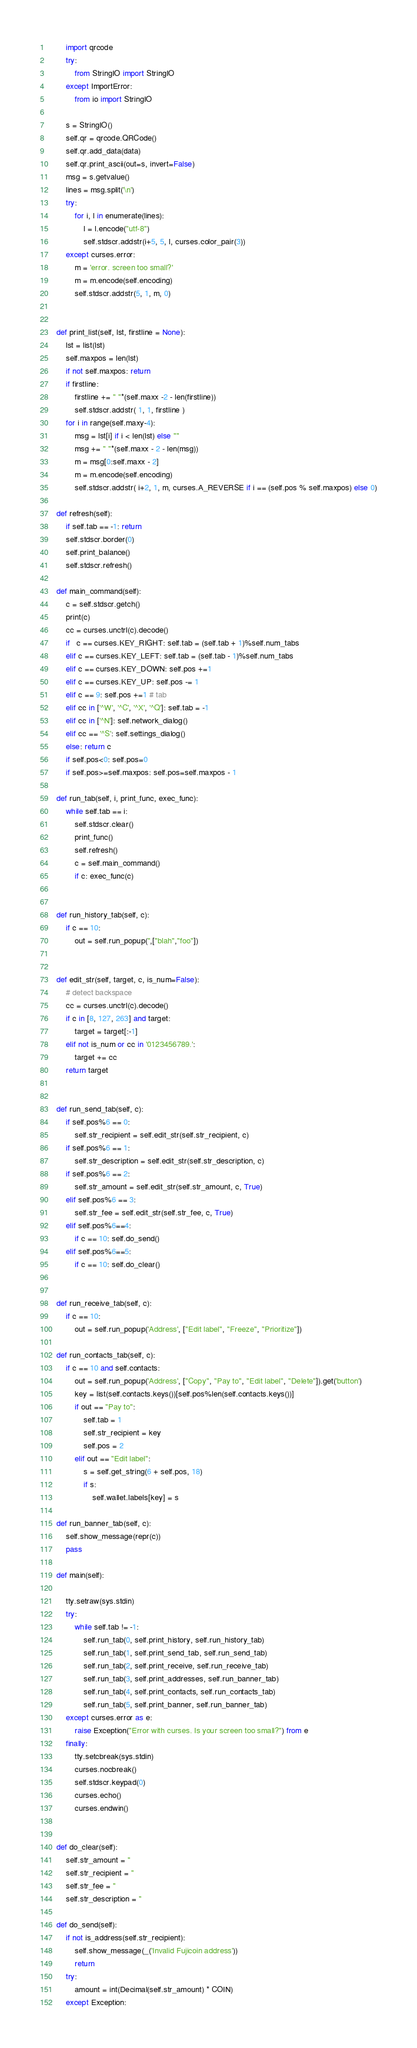Convert code to text. <code><loc_0><loc_0><loc_500><loc_500><_Python_>        import qrcode
        try:
            from StringIO import StringIO
        except ImportError:
            from io import StringIO

        s = StringIO()
        self.qr = qrcode.QRCode()
        self.qr.add_data(data)
        self.qr.print_ascii(out=s, invert=False)
        msg = s.getvalue()
        lines = msg.split('\n')
        try:
            for i, l in enumerate(lines):
                l = l.encode("utf-8")
                self.stdscr.addstr(i+5, 5, l, curses.color_pair(3))
        except curses.error:
            m = 'error. screen too small?'
            m = m.encode(self.encoding)
            self.stdscr.addstr(5, 1, m, 0)


    def print_list(self, lst, firstline = None):
        lst = list(lst)
        self.maxpos = len(lst)
        if not self.maxpos: return
        if firstline:
            firstline += " "*(self.maxx -2 - len(firstline))
            self.stdscr.addstr( 1, 1, firstline )
        for i in range(self.maxy-4):
            msg = lst[i] if i < len(lst) else ""
            msg += " "*(self.maxx - 2 - len(msg))
            m = msg[0:self.maxx - 2]
            m = m.encode(self.encoding)
            self.stdscr.addstr( i+2, 1, m, curses.A_REVERSE if i == (self.pos % self.maxpos) else 0)

    def refresh(self):
        if self.tab == -1: return
        self.stdscr.border(0)
        self.print_balance()
        self.stdscr.refresh()

    def main_command(self):
        c = self.stdscr.getch()
        print(c)
        cc = curses.unctrl(c).decode()
        if   c == curses.KEY_RIGHT: self.tab = (self.tab + 1)%self.num_tabs
        elif c == curses.KEY_LEFT: self.tab = (self.tab - 1)%self.num_tabs
        elif c == curses.KEY_DOWN: self.pos +=1
        elif c == curses.KEY_UP: self.pos -= 1
        elif c == 9: self.pos +=1 # tab
        elif cc in ['^W', '^C', '^X', '^Q']: self.tab = -1
        elif cc in ['^N']: self.network_dialog()
        elif cc == '^S': self.settings_dialog()
        else: return c
        if self.pos<0: self.pos=0
        if self.pos>=self.maxpos: self.pos=self.maxpos - 1

    def run_tab(self, i, print_func, exec_func):
        while self.tab == i:
            self.stdscr.clear()
            print_func()
            self.refresh()
            c = self.main_command()
            if c: exec_func(c)


    def run_history_tab(self, c):
        if c == 10:
            out = self.run_popup('',["blah","foo"])


    def edit_str(self, target, c, is_num=False):
        # detect backspace
        cc = curses.unctrl(c).decode()
        if c in [8, 127, 263] and target:
            target = target[:-1]
        elif not is_num or cc in '0123456789.':
            target += cc
        return target


    def run_send_tab(self, c):
        if self.pos%6 == 0:
            self.str_recipient = self.edit_str(self.str_recipient, c)
        if self.pos%6 == 1:
            self.str_description = self.edit_str(self.str_description, c)
        if self.pos%6 == 2:
            self.str_amount = self.edit_str(self.str_amount, c, True)
        elif self.pos%6 == 3:
            self.str_fee = self.edit_str(self.str_fee, c, True)
        elif self.pos%6==4:
            if c == 10: self.do_send()
        elif self.pos%6==5:
            if c == 10: self.do_clear()


    def run_receive_tab(self, c):
        if c == 10:
            out = self.run_popup('Address', ["Edit label", "Freeze", "Prioritize"])

    def run_contacts_tab(self, c):
        if c == 10 and self.contacts:
            out = self.run_popup('Address', ["Copy", "Pay to", "Edit label", "Delete"]).get('button')
            key = list(self.contacts.keys())[self.pos%len(self.contacts.keys())]
            if out == "Pay to":
                self.tab = 1
                self.str_recipient = key
                self.pos = 2
            elif out == "Edit label":
                s = self.get_string(6 + self.pos, 18)
                if s:
                    self.wallet.labels[key] = s

    def run_banner_tab(self, c):
        self.show_message(repr(c))
        pass

    def main(self):

        tty.setraw(sys.stdin)
        try:
            while self.tab != -1:
                self.run_tab(0, self.print_history, self.run_history_tab)
                self.run_tab(1, self.print_send_tab, self.run_send_tab)
                self.run_tab(2, self.print_receive, self.run_receive_tab)
                self.run_tab(3, self.print_addresses, self.run_banner_tab)
                self.run_tab(4, self.print_contacts, self.run_contacts_tab)
                self.run_tab(5, self.print_banner, self.run_banner_tab)
        except curses.error as e:
            raise Exception("Error with curses. Is your screen too small?") from e
        finally:
            tty.setcbreak(sys.stdin)
            curses.nocbreak()
            self.stdscr.keypad(0)
            curses.echo()
            curses.endwin()


    def do_clear(self):
        self.str_amount = ''
        self.str_recipient = ''
        self.str_fee = ''
        self.str_description = ''

    def do_send(self):
        if not is_address(self.str_recipient):
            self.show_message(_('Invalid Fujicoin address'))
            return
        try:
            amount = int(Decimal(self.str_amount) * COIN)
        except Exception:</code> 